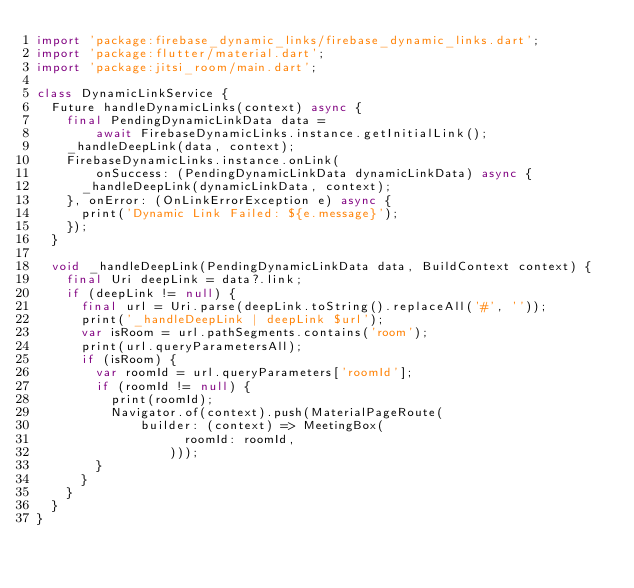Convert code to text. <code><loc_0><loc_0><loc_500><loc_500><_Dart_>import 'package:firebase_dynamic_links/firebase_dynamic_links.dart';
import 'package:flutter/material.dart';
import 'package:jitsi_room/main.dart';

class DynamicLinkService {
  Future handleDynamicLinks(context) async {
    final PendingDynamicLinkData data =
        await FirebaseDynamicLinks.instance.getInitialLink();
    _handleDeepLink(data, context);
    FirebaseDynamicLinks.instance.onLink(
        onSuccess: (PendingDynamicLinkData dynamicLinkData) async {
      _handleDeepLink(dynamicLinkData, context);
    }, onError: (OnLinkErrorException e) async {
      print('Dynamic Link Failed: ${e.message}');
    });
  }

  void _handleDeepLink(PendingDynamicLinkData data, BuildContext context) {
    final Uri deepLink = data?.link;
    if (deepLink != null) {
      final url = Uri.parse(deepLink.toString().replaceAll('#', ''));
      print('_handleDeepLink | deepLink $url');
      var isRoom = url.pathSegments.contains('room');
      print(url.queryParametersAll);
      if (isRoom) {
        var roomId = url.queryParameters['roomId'];
        if (roomId != null) {
          print(roomId);
          Navigator.of(context).push(MaterialPageRoute(
              builder: (context) => MeetingBox(
                    roomId: roomId,
                  )));
        }
      }
    }
  }
}
</code> 